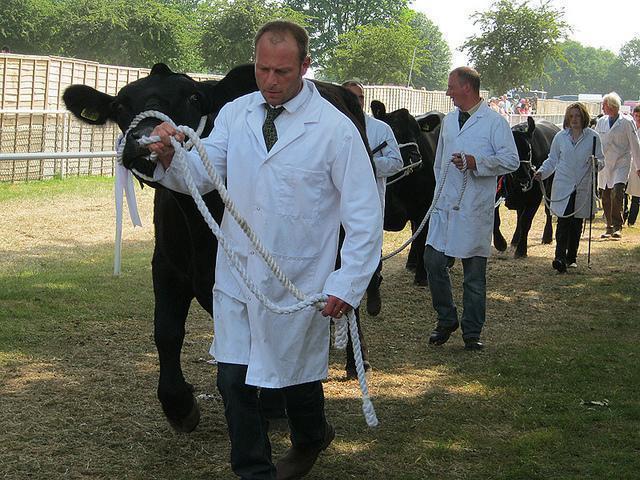Who are these grownups?
Answer the question by selecting the correct answer among the 4 following choices and explain your choice with a short sentence. The answer should be formatted with the following format: `Answer: choice
Rationale: rationale.`
Options: Cow buyers, medical workers, farmers, visitors. Answer: medical workers.
Rationale: The men are wearing white. 